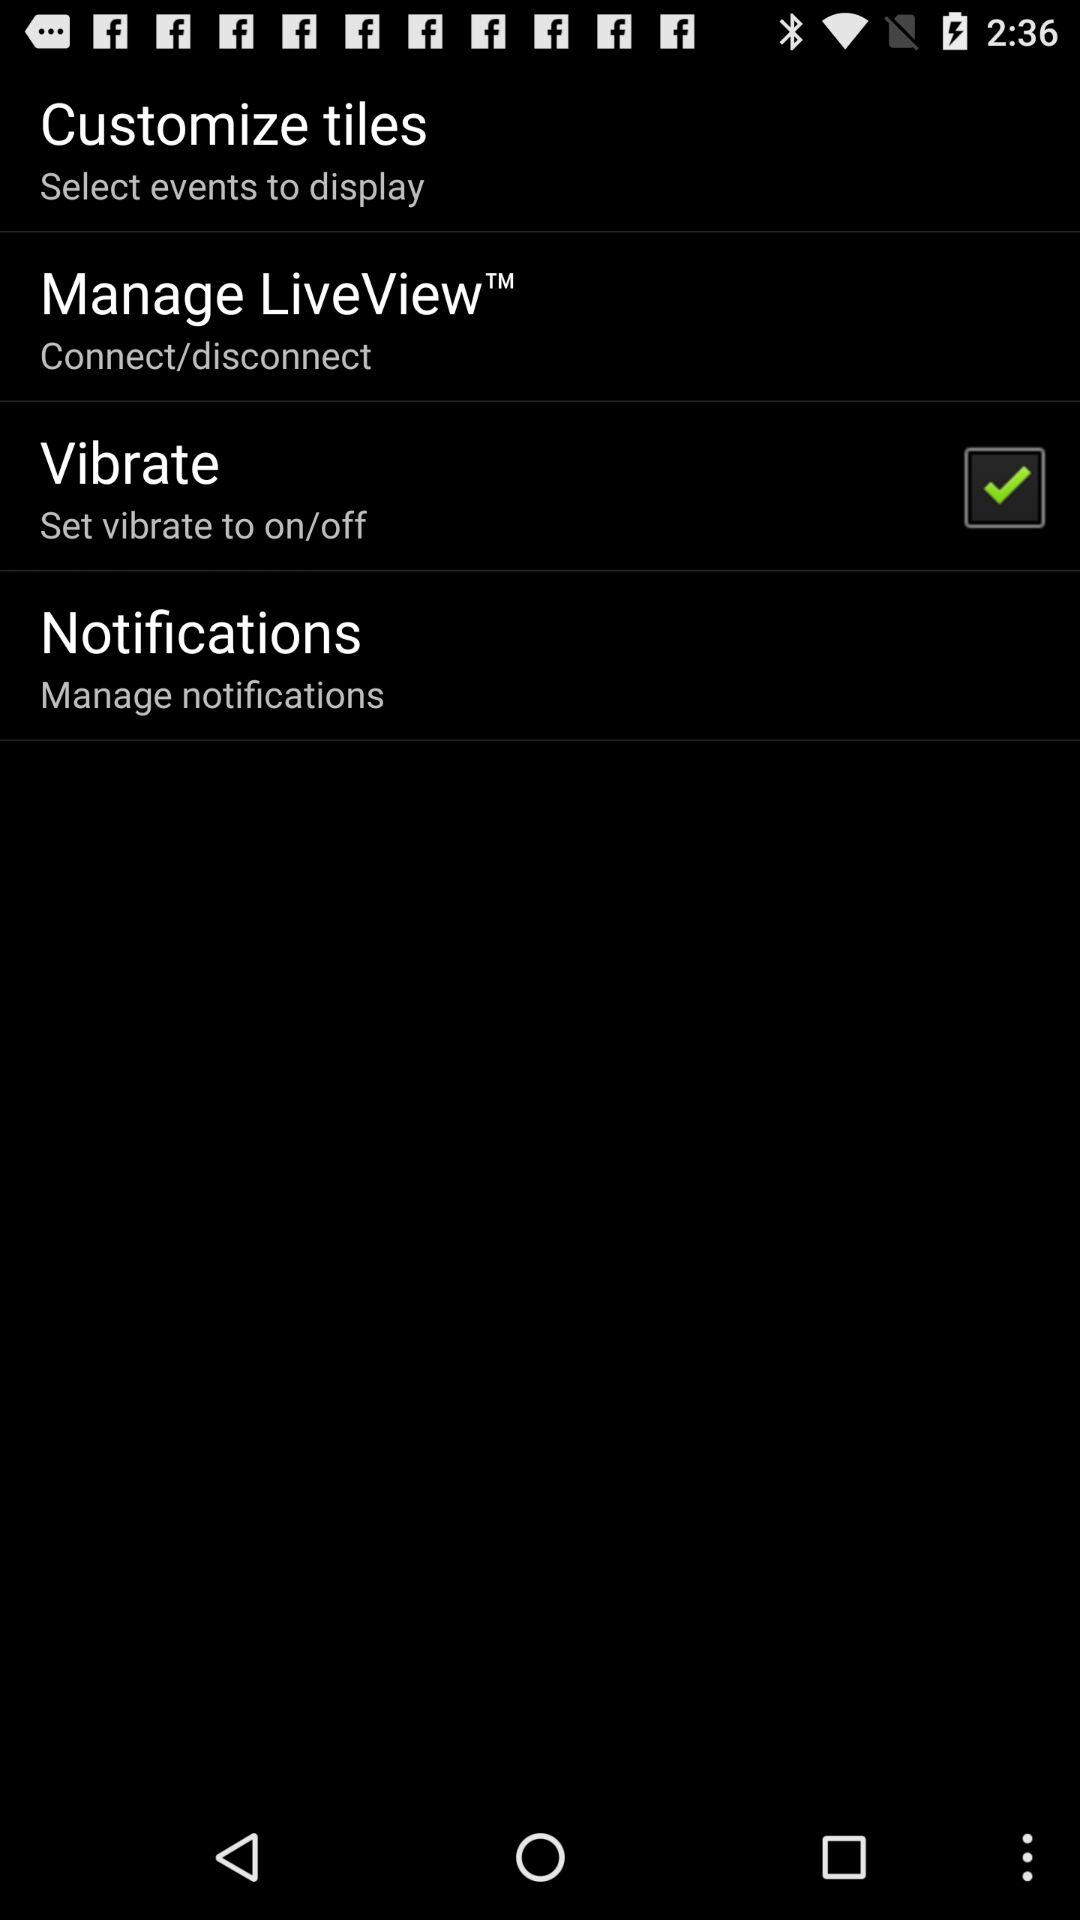How many items have text and a checkbox?
Answer the question using a single word or phrase. 1 